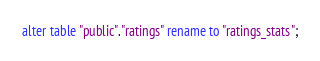<code> <loc_0><loc_0><loc_500><loc_500><_SQL_>
alter table "public"."ratings" rename to "ratings_stats";</code> 